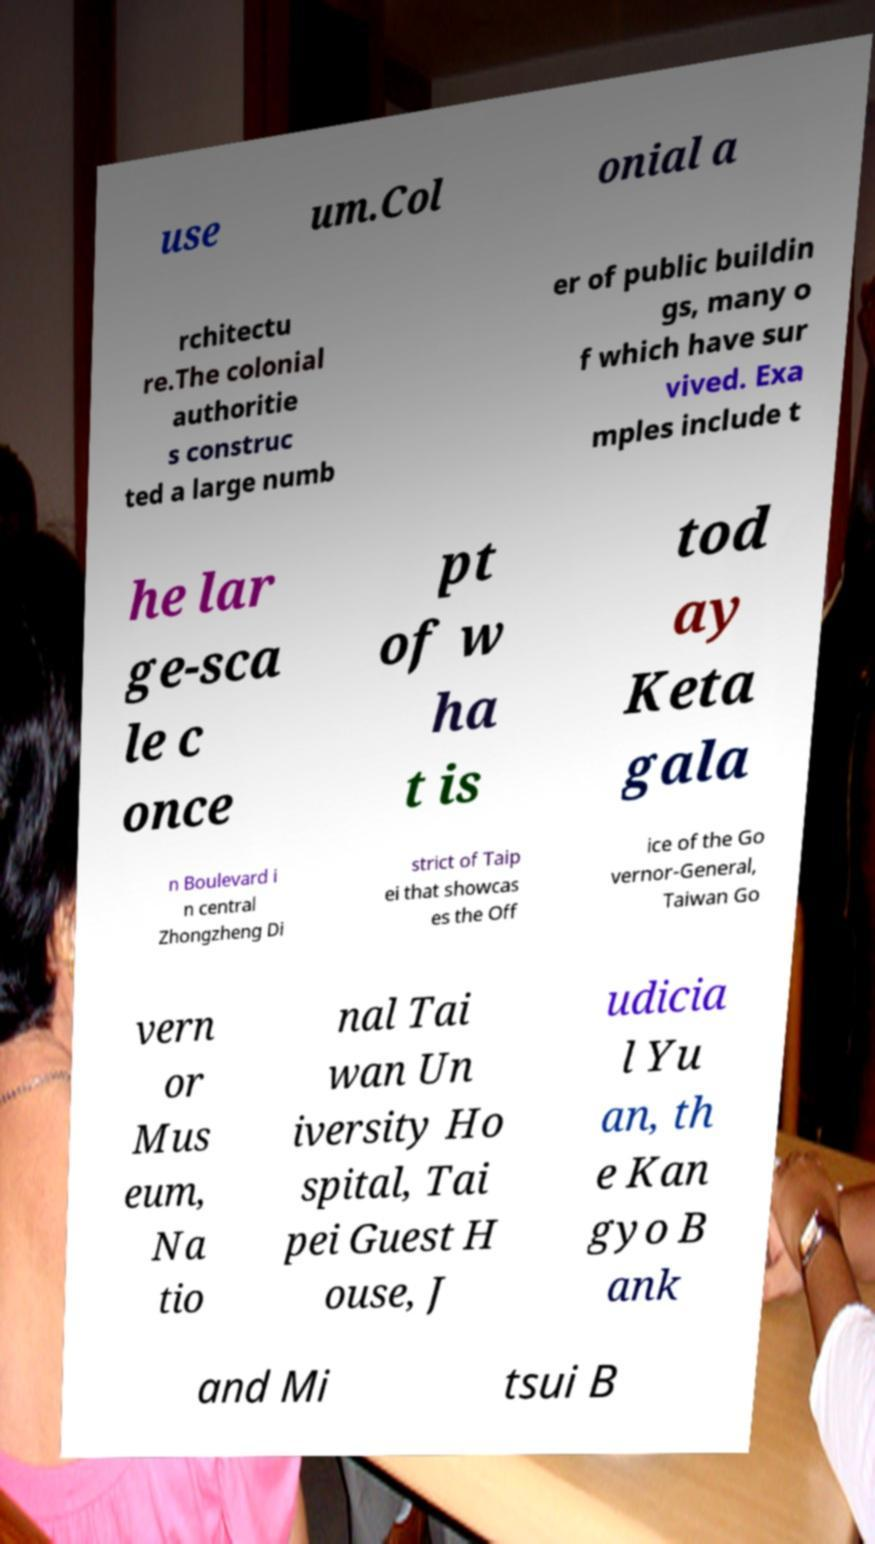Please identify and transcribe the text found in this image. use um.Col onial a rchitectu re.The colonial authoritie s construc ted a large numb er of public buildin gs, many o f which have sur vived. Exa mples include t he lar ge-sca le c once pt of w ha t is tod ay Keta gala n Boulevard i n central Zhongzheng Di strict of Taip ei that showcas es the Off ice of the Go vernor-General, Taiwan Go vern or Mus eum, Na tio nal Tai wan Un iversity Ho spital, Tai pei Guest H ouse, J udicia l Yu an, th e Kan gyo B ank and Mi tsui B 